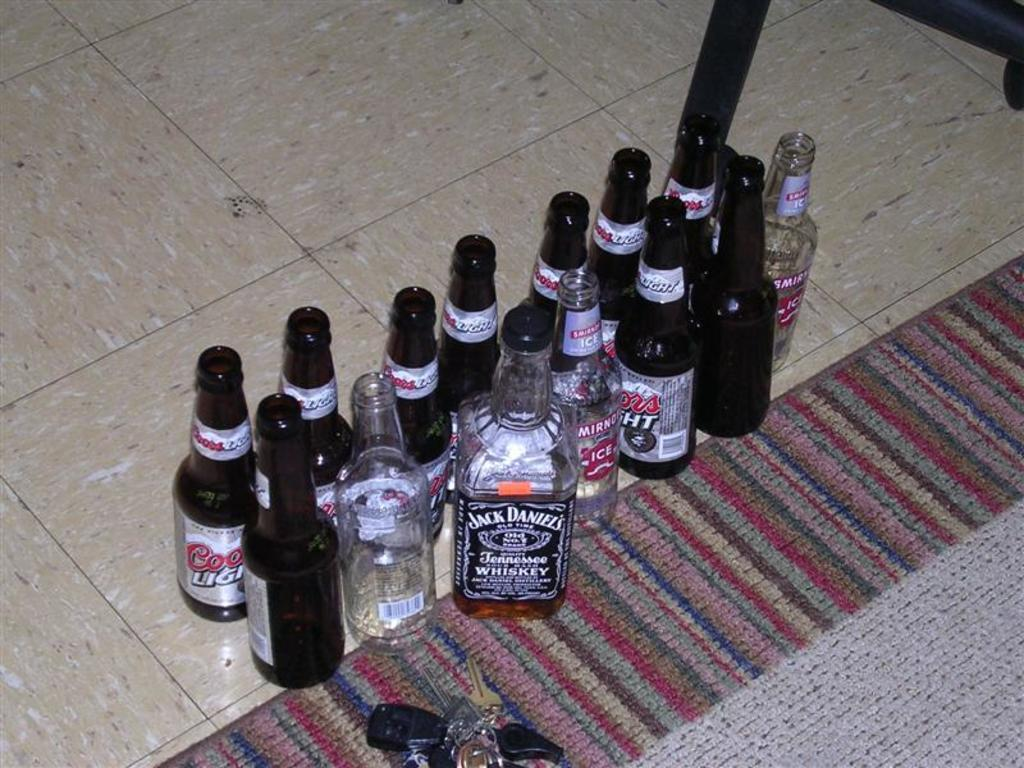<image>
Share a concise interpretation of the image provided. A bottle of Jack Daniels with various bottles of Coors light. 